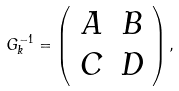<formula> <loc_0><loc_0><loc_500><loc_500>G ^ { - 1 } _ { k } = \left ( \begin{array} { c c } A & B \\ C & D \end{array} \right ) ,</formula> 